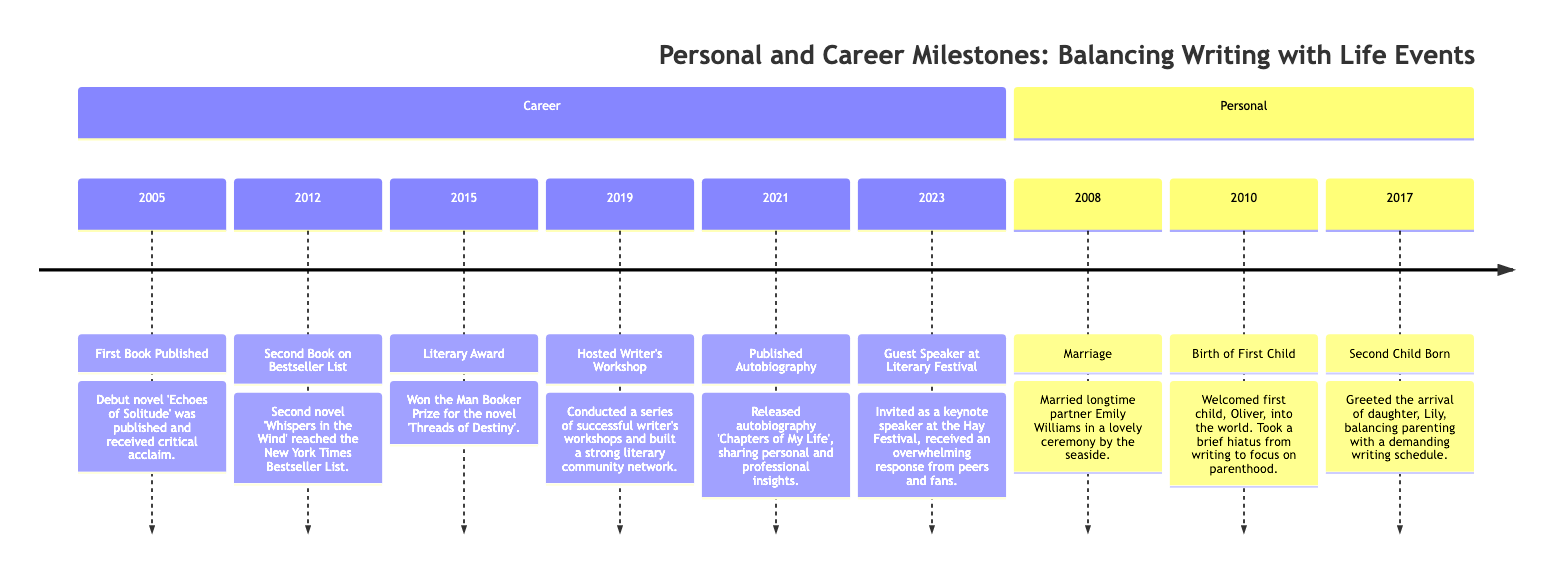What was the first book published? The timeline indicates that the first book published was 'Echoes of Solitude' in 2005. This is the earliest event listed under the Career section.
Answer: Echoes of Solitude In which year did the author marry? The timeline shows that the author married in 2008, which is specified as the Marriage event. This is the first personal event that appears on the timeline.
Answer: 2008 How many children does the author have? By examining the personal events on the timeline, there are two entries indicating the birth of two children: Oliver in 2010 and Lily in 2017. Therefore, the total count is two.
Answer: 2 What was the literary award won by the author? According to the timeline, the author won the Man Booker Prize in 2015 for the novel 'Threads of Destiny'. This specific event clearly states the type of award won.
Answer: Man Booker Prize Which book reached the New York Times Bestseller List? The timeline indicates that the second novel 'Whispers in the Wind' achieved this status in 2012. This is mentioned clearly in the Career section of the timeline.
Answer: Whispers in the Wind What significant event occurred in 2019? In 2019, the author hosted a series of writer's workshops, as highlighted in the timeline. This is a notable event in their career.
Answer: Hosted Writer's Workshop What was published in 2021? The author released their autobiography titled 'Chapters of My Life' in 2021, which is mentioned in the Career section of the timeline. This signifies a key milestone in their personal and professional journey.
Answer: Autobiography What is the order of the author's children being born? The timeline lists the birth of the first child, Oliver, in 2010, followed by the second child, Lily, in 2017. By analyzing these entries, it’s clear that Oliver is the firstborn and Lily is the second.
Answer: Oliver, Lily How long was the author's writing hiatus after their first child? The timeline states that after the birth of Oliver in 2010, the author took a brief hiatus from writing to focus on parenthood. This implies a certain duration of time, but not a specific number of years. The phrasing "brief hiatus" suggests that it may not have been an extensive time.
Answer: Brief What major event did the author participate in 2023? The timeline specifies that in 2023, the author was invited as a guest speaker at the Hay Festival, noted as a significant event where they received a positive response.
Answer: Guest Speaker at Literary Festival 